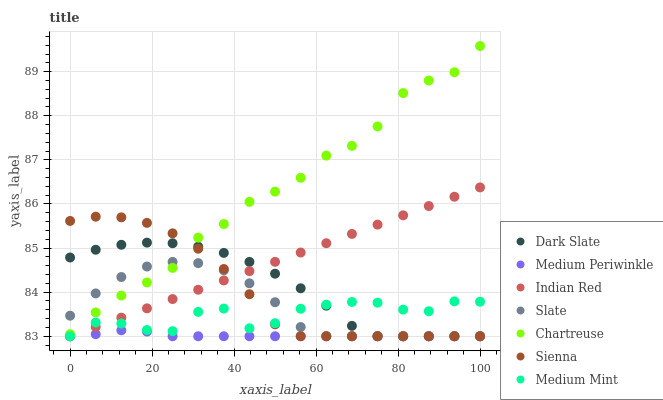Does Medium Periwinkle have the minimum area under the curve?
Answer yes or no. Yes. Does Chartreuse have the maximum area under the curve?
Answer yes or no. Yes. Does Slate have the minimum area under the curve?
Answer yes or no. No. Does Slate have the maximum area under the curve?
Answer yes or no. No. Is Indian Red the smoothest?
Answer yes or no. Yes. Is Medium Mint the roughest?
Answer yes or no. Yes. Is Slate the smoothest?
Answer yes or no. No. Is Slate the roughest?
Answer yes or no. No. Does Medium Mint have the lowest value?
Answer yes or no. Yes. Does Chartreuse have the lowest value?
Answer yes or no. No. Does Chartreuse have the highest value?
Answer yes or no. Yes. Does Slate have the highest value?
Answer yes or no. No. Is Medium Periwinkle less than Chartreuse?
Answer yes or no. Yes. Is Chartreuse greater than Medium Mint?
Answer yes or no. Yes. Does Medium Periwinkle intersect Indian Red?
Answer yes or no. Yes. Is Medium Periwinkle less than Indian Red?
Answer yes or no. No. Is Medium Periwinkle greater than Indian Red?
Answer yes or no. No. Does Medium Periwinkle intersect Chartreuse?
Answer yes or no. No. 